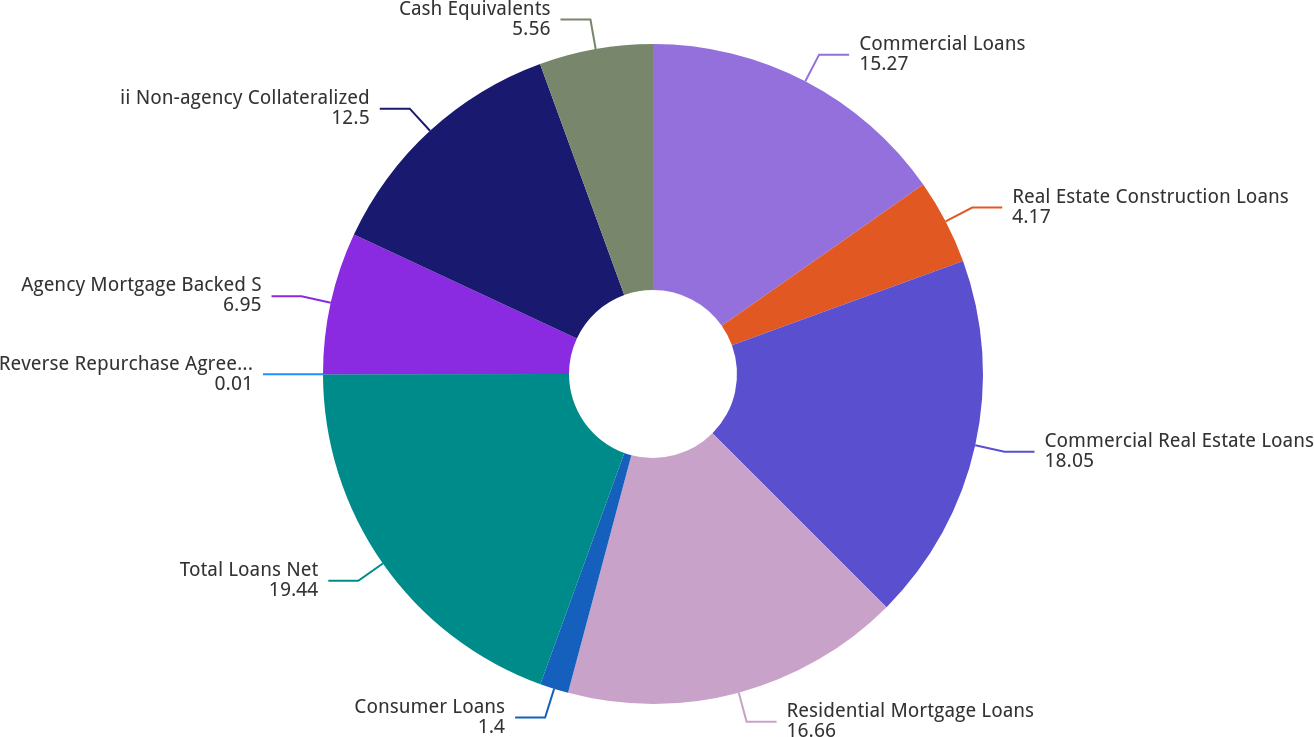Convert chart. <chart><loc_0><loc_0><loc_500><loc_500><pie_chart><fcel>Commercial Loans<fcel>Real Estate Construction Loans<fcel>Commercial Real Estate Loans<fcel>Residential Mortgage Loans<fcel>Consumer Loans<fcel>Total Loans Net<fcel>Reverse Repurchase Agreements<fcel>Agency Mortgage Backed S<fcel>ii Non-agency Collateralized<fcel>Cash Equivalents<nl><fcel>15.27%<fcel>4.17%<fcel>18.05%<fcel>16.66%<fcel>1.4%<fcel>19.44%<fcel>0.01%<fcel>6.95%<fcel>12.5%<fcel>5.56%<nl></chart> 